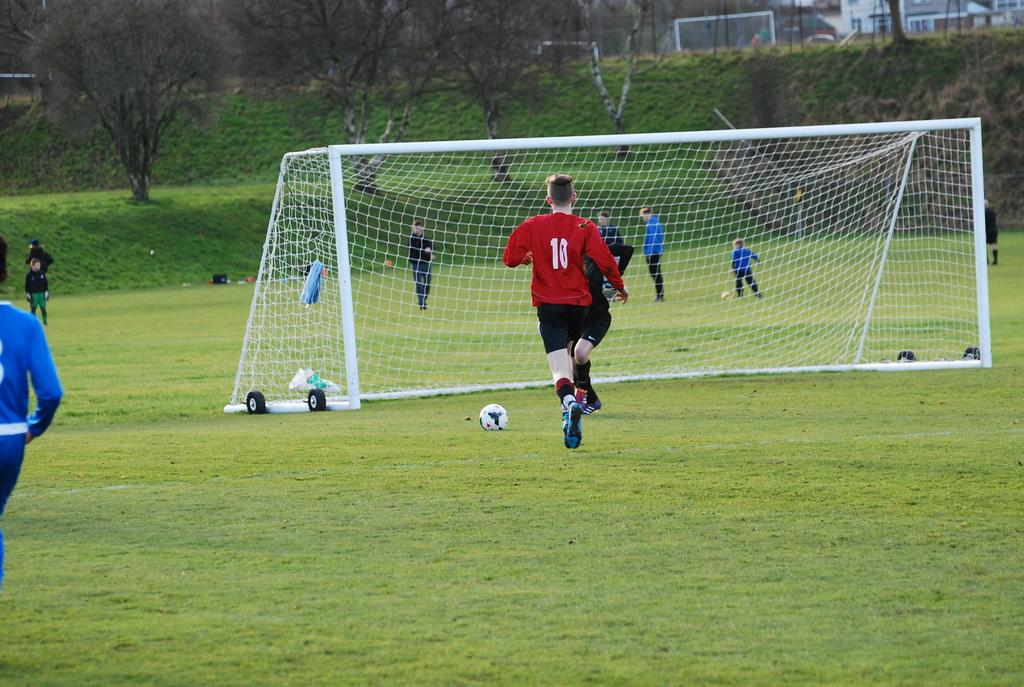<image>
Summarize the visual content of the image. A man wearing number 10 jersey is running toward the goal post. 